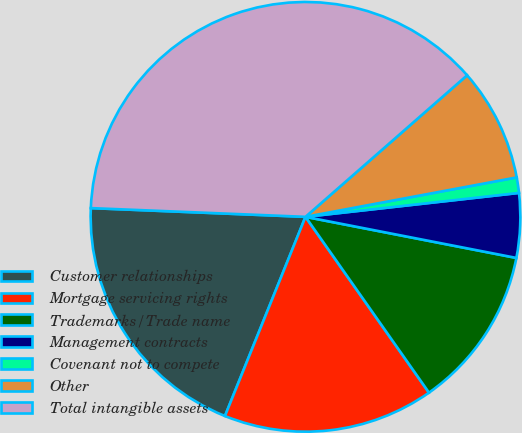Convert chart to OTSL. <chart><loc_0><loc_0><loc_500><loc_500><pie_chart><fcel>Customer relationships<fcel>Mortgage servicing rights<fcel>Trademarks/Trade name<fcel>Management contracts<fcel>Covenant not to compete<fcel>Other<fcel>Total intangible assets<nl><fcel>19.53%<fcel>15.86%<fcel>12.19%<fcel>4.84%<fcel>1.16%<fcel>8.51%<fcel>37.9%<nl></chart> 